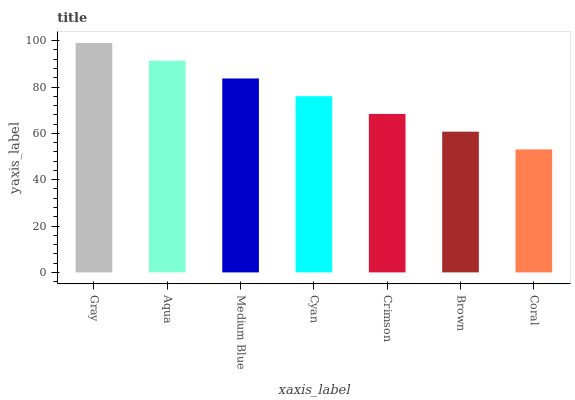Is Coral the minimum?
Answer yes or no. Yes. Is Gray the maximum?
Answer yes or no. Yes. Is Aqua the minimum?
Answer yes or no. No. Is Aqua the maximum?
Answer yes or no. No. Is Gray greater than Aqua?
Answer yes or no. Yes. Is Aqua less than Gray?
Answer yes or no. Yes. Is Aqua greater than Gray?
Answer yes or no. No. Is Gray less than Aqua?
Answer yes or no. No. Is Cyan the high median?
Answer yes or no. Yes. Is Cyan the low median?
Answer yes or no. Yes. Is Crimson the high median?
Answer yes or no. No. Is Medium Blue the low median?
Answer yes or no. No. 